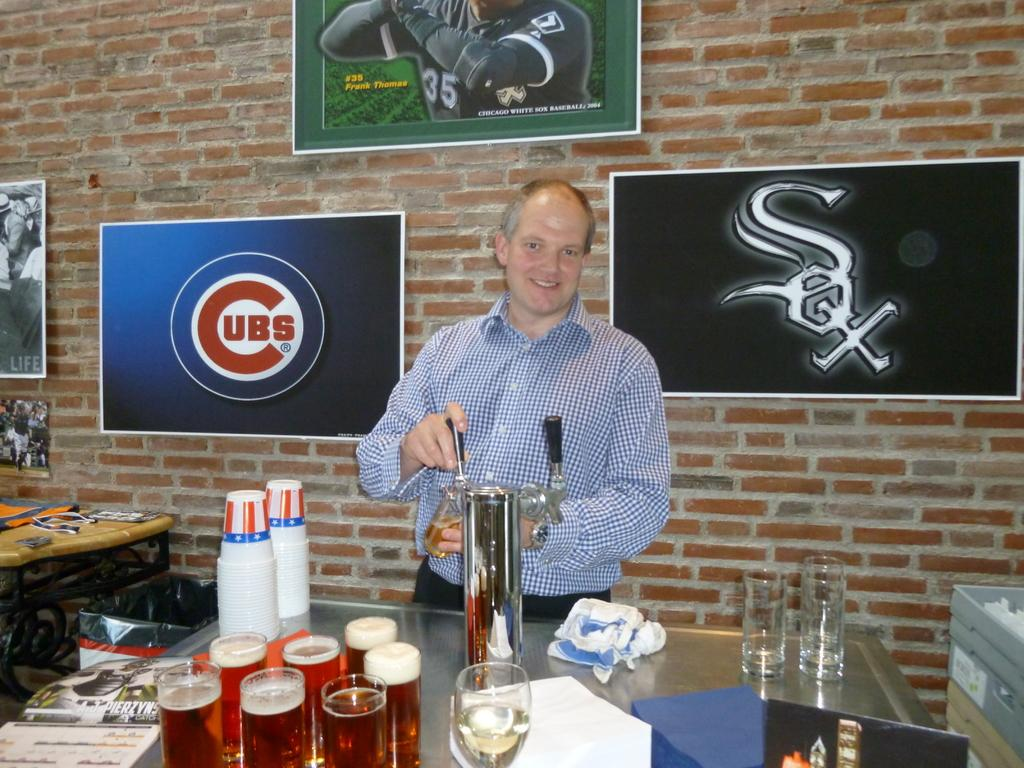<image>
Give a short and clear explanation of the subsequent image. A man drawing a beer from a tap as he stands in front of a Cubs poster. 